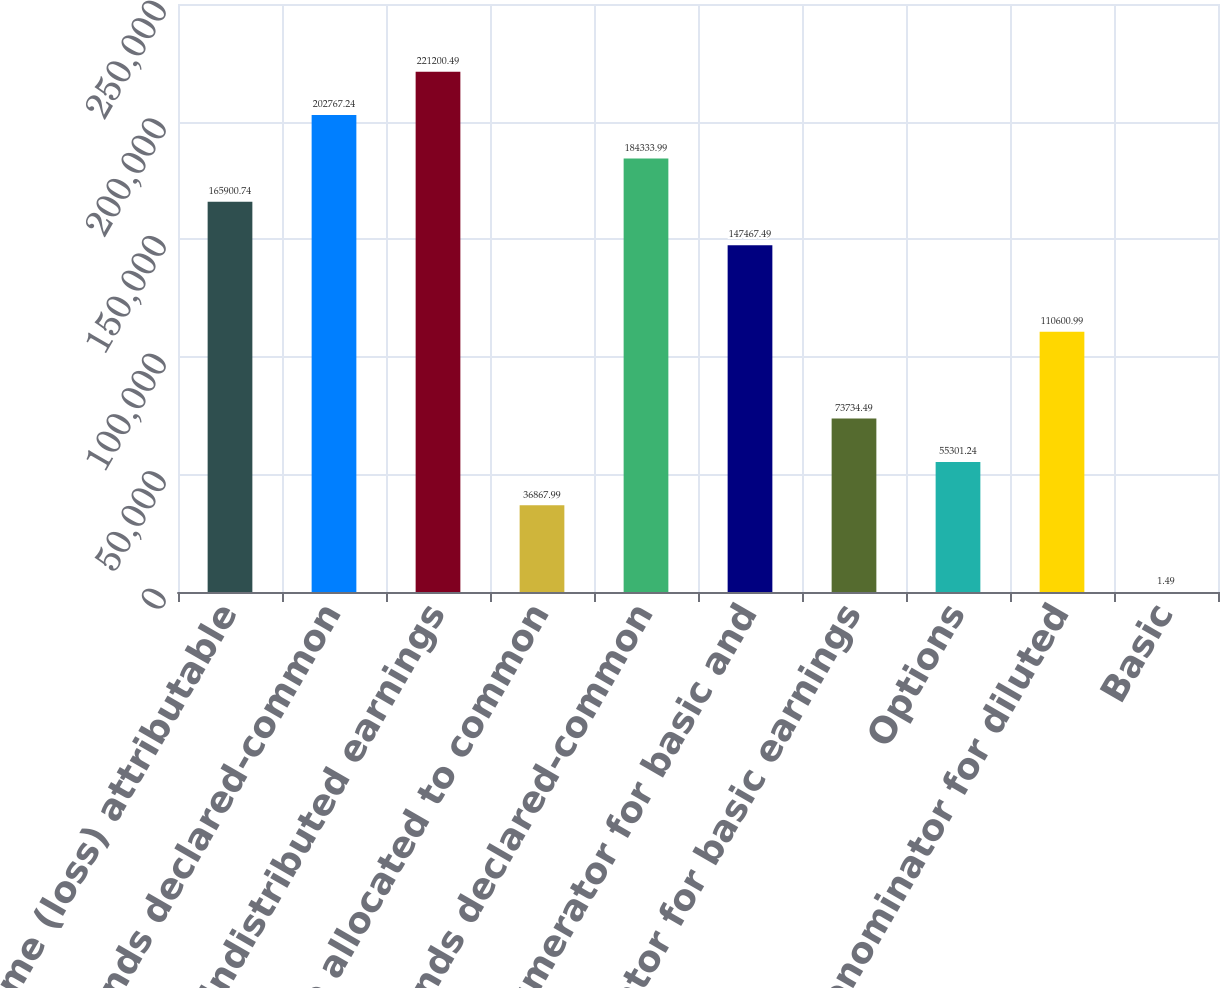Convert chart. <chart><loc_0><loc_0><loc_500><loc_500><bar_chart><fcel>Net income (loss) attributable<fcel>Less dividends declared-common<fcel>Undistributed earnings<fcel>Percentage allocated to common<fcel>Add dividends declared-common<fcel>Numerator for basic and<fcel>Denominator for basic earnings<fcel>Options<fcel>Denominator for diluted<fcel>Basic<nl><fcel>165901<fcel>202767<fcel>221200<fcel>36868<fcel>184334<fcel>147467<fcel>73734.5<fcel>55301.2<fcel>110601<fcel>1.49<nl></chart> 